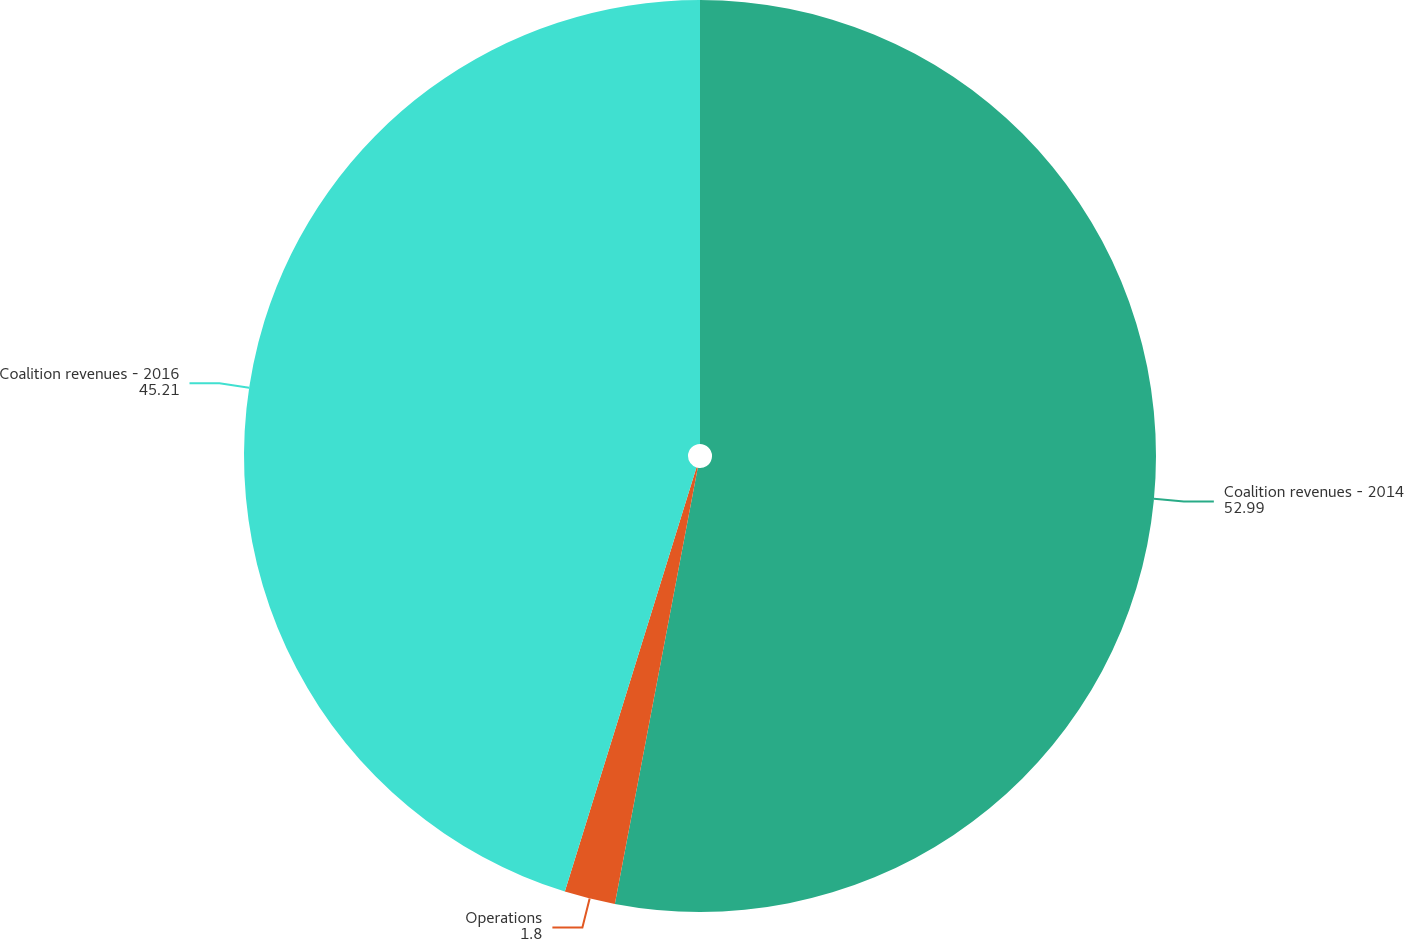Convert chart to OTSL. <chart><loc_0><loc_0><loc_500><loc_500><pie_chart><fcel>Coalition revenues - 2014<fcel>Operations<fcel>Coalition revenues - 2016<nl><fcel>52.99%<fcel>1.8%<fcel>45.21%<nl></chart> 